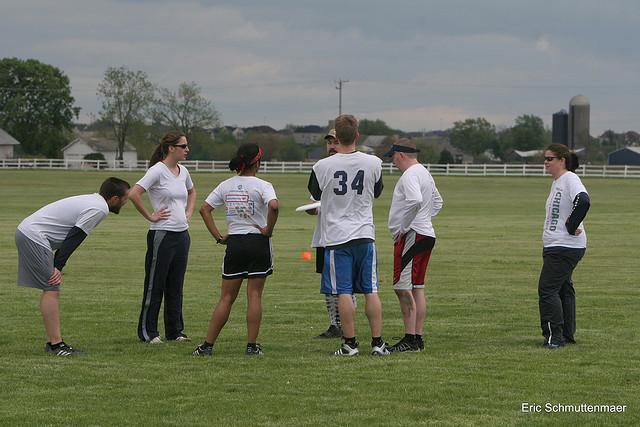How many players have visible numbers?
Give a very brief answer. 1. How many people are shown?
Give a very brief answer. 7. How many adults are present?
Give a very brief answer. 7. How many guys that are shirtless?
Give a very brief answer. 0. How many players are on the field?
Give a very brief answer. 7. How many players are there?
Give a very brief answer. 7. How many people are there?
Give a very brief answer. 6. 